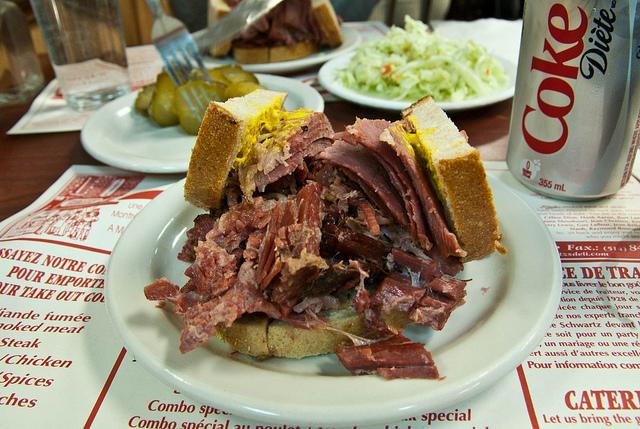What brand of soda is shown?
Keep it brief. Coke. Is there plenty of meat on the sandwich?
Write a very short answer. Yes. Are there any pickles on the table?
Keep it brief. Yes. 